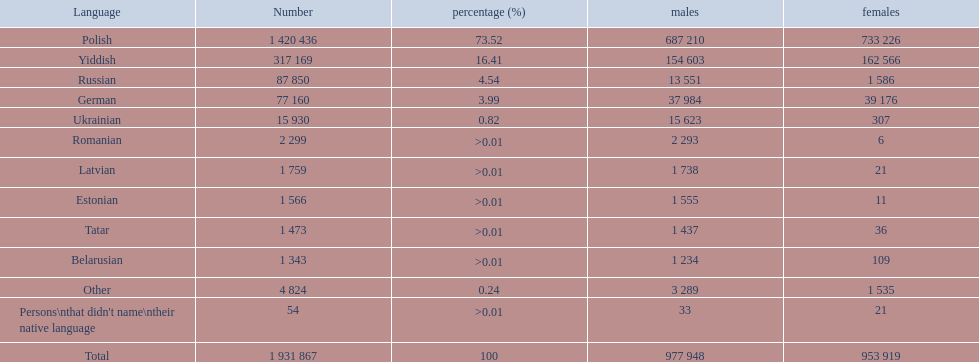How many languages are presented? Polish, Yiddish, Russian, German, Ukrainian, Romanian, Latvian, Estonian, Tatar, Belarusian, Other. Which language ranks third? Russian. What language is most widely spoken after that particular one? German. What are the tongues spoken in the warsaw governorate? Polish, Yiddish, Russian, German, Ukrainian, Romanian, Latvian, Estonian, Tatar, Belarusian, Other. What proportion is polish? 73.52. What is the subsequent largest percentage? 16.41. Would you be able to parse every entry in this table? {'header': ['Language', 'Number', 'percentage (%)', 'males', 'females'], 'rows': [['Polish', '1 420 436', '73.52', '687 210', '733 226'], ['Yiddish', '317 169', '16.41', '154 603', '162 566'], ['Russian', '87 850', '4.54', '13 551', '1 586'], ['German', '77 160', '3.99', '37 984', '39 176'], ['Ukrainian', '15 930', '0.82', '15 623', '307'], ['Romanian', '2 299', '>0.01', '2 293', '6'], ['Latvian', '1 759', '>0.01', '1 738', '21'], ['Estonian', '1 566', '>0.01', '1 555', '11'], ['Tatar', '1 473', '>0.01', '1 437', '36'], ['Belarusian', '1 343', '>0.01', '1 234', '109'], ['Other', '4 824', '0.24', '3 289', '1 535'], ["Persons\\nthat didn't name\\ntheir native language", '54', '>0.01', '33', '21'], ['Total', '1 931 867', '100', '977 948', '953 919']]} Which language corresponds to this percentage? Yiddish. 